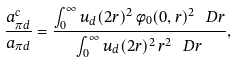Convert formula to latex. <formula><loc_0><loc_0><loc_500><loc_500>\frac { a _ { \pi d } ^ { c } } { a _ { \pi d } } = \frac { \int _ { 0 } ^ { \infty } u _ { d } ( 2 r ) ^ { 2 } \, \phi _ { 0 } ( 0 , r ) ^ { 2 } \, \ D r } { \int _ { 0 } ^ { \infty } u _ { d } ( 2 r ) ^ { 2 } \, r ^ { 2 } \, \ D r } ,</formula> 